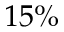<formula> <loc_0><loc_0><loc_500><loc_500>1 5 \%</formula> 